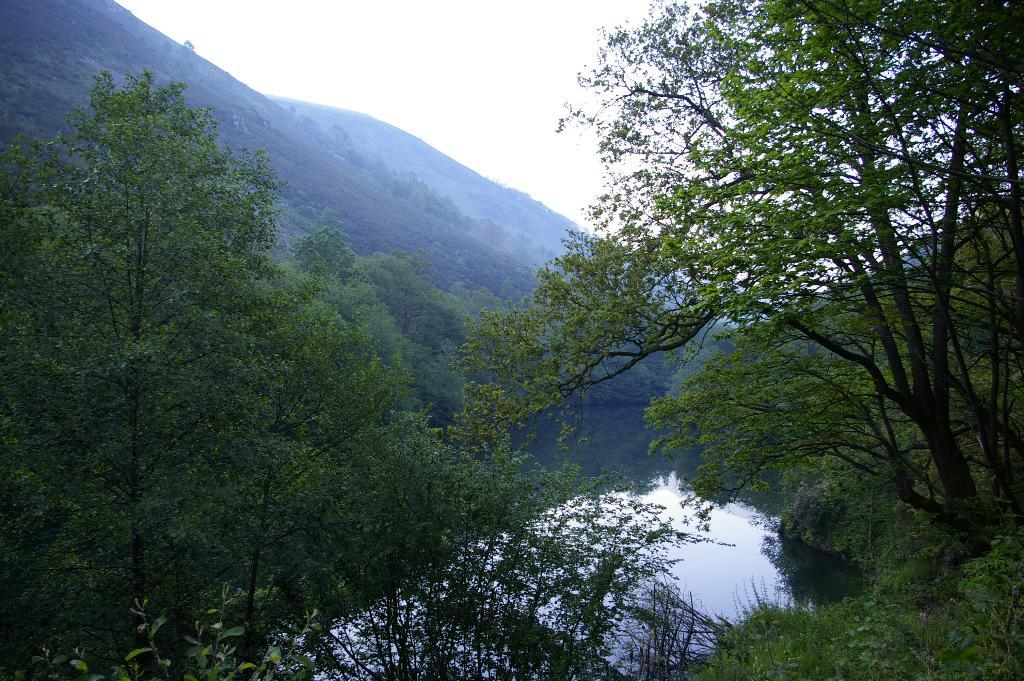What can be seen in the left corner of the image? There are trees in the left corner of the image. What can be seen in the right corner of the image? There are trees in the right corner of the image. What is located at the bottom of the image? There is water at the bottom of the image. What is visible in the background of the image? There are trees and mountains in the background of the image. What is visible at the top of the image? The sky is visible at the top of the image. How many pies are being photographed by the camera in the image? There is no camera or pies present in the image. What is the interest rate of the loan mentioned in the image? There is no mention of a loan or interest rate in the image. 